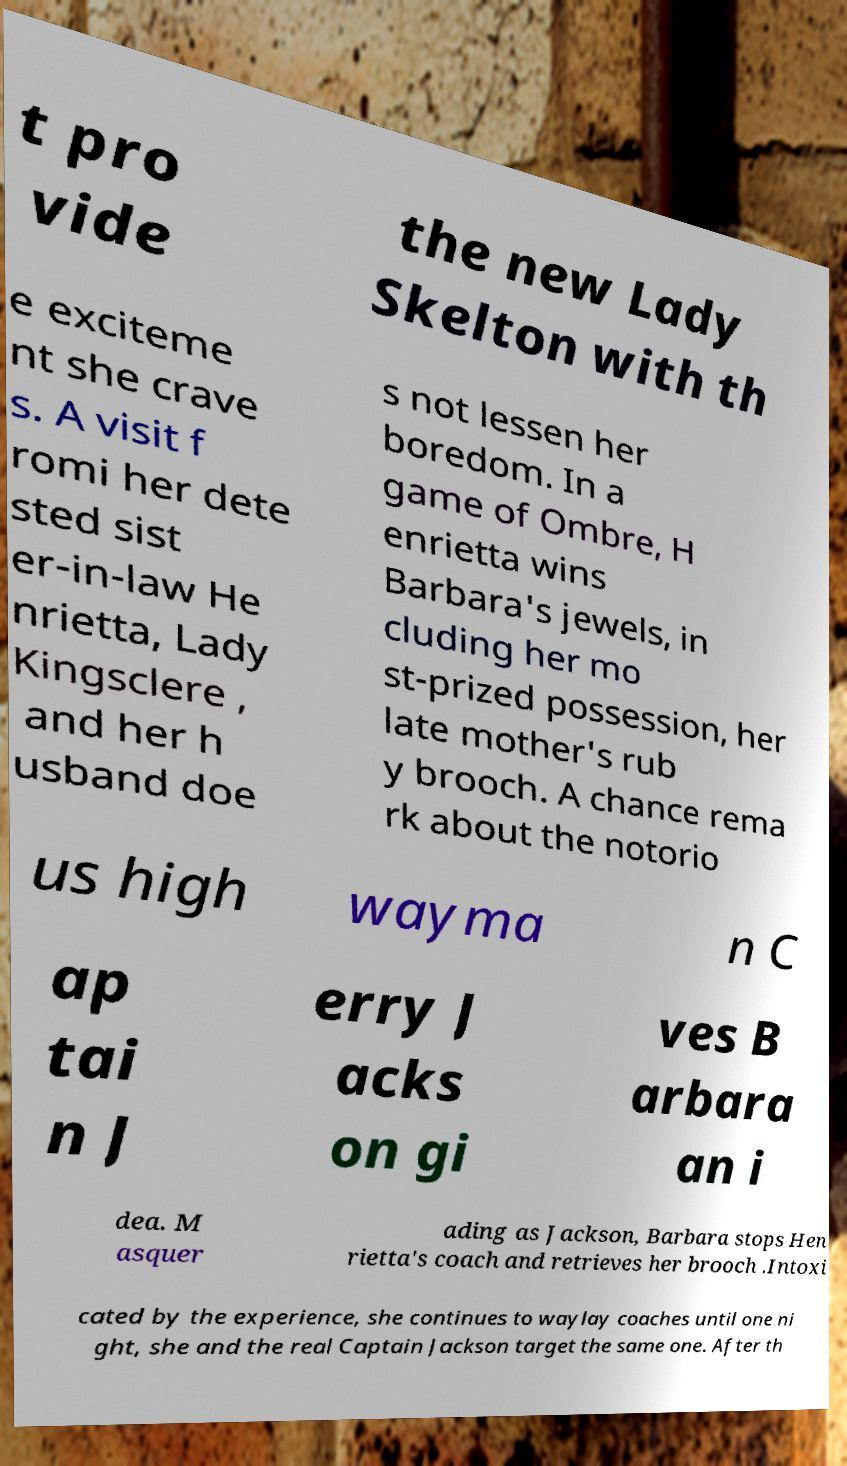Please identify and transcribe the text found in this image. t pro vide the new Lady Skelton with th e exciteme nt she crave s. A visit f romi her dete sted sist er-in-law He nrietta, Lady Kingsclere , and her h usband doe s not lessen her boredom. In a game of Ombre, H enrietta wins Barbara's jewels, in cluding her mo st-prized possession, her late mother's rub y brooch. A chance rema rk about the notorio us high wayma n C ap tai n J erry J acks on gi ves B arbara an i dea. M asquer ading as Jackson, Barbara stops Hen rietta's coach and retrieves her brooch .Intoxi cated by the experience, she continues to waylay coaches until one ni ght, she and the real Captain Jackson target the same one. After th 